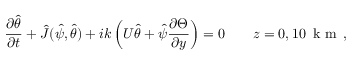Convert formula to latex. <formula><loc_0><loc_0><loc_500><loc_500>\frac { \partial \hat { \theta } } { \partial t } + \hat { J } ( \hat { \psi } , \hat { \theta } ) + i k \left ( U \hat { \theta } + \hat { \psi } \frac { \partial \Theta } { \partial y } \right ) = 0 \quad z = 0 , 1 0 \, k m \, ,</formula> 